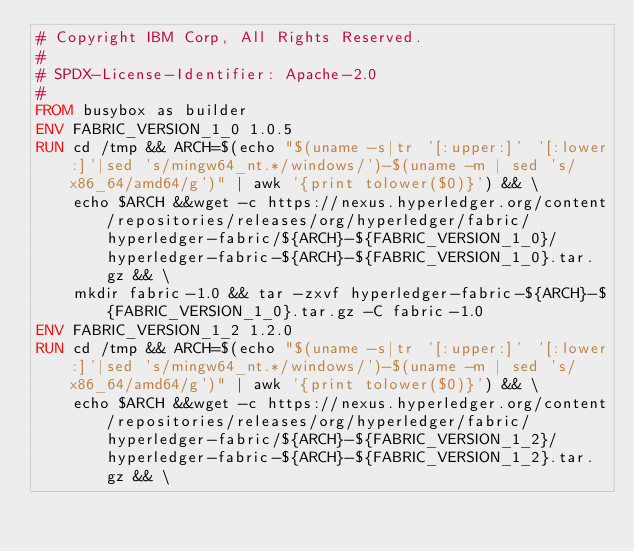Convert code to text. <code><loc_0><loc_0><loc_500><loc_500><_Dockerfile_># Copyright IBM Corp, All Rights Reserved.
#
# SPDX-License-Identifier: Apache-2.0
#
FROM busybox as builder
ENV FABRIC_VERSION_1_0 1.0.5
RUN cd /tmp && ARCH=$(echo "$(uname -s|tr '[:upper:]' '[:lower:]'|sed 's/mingw64_nt.*/windows/')-$(uname -m | sed 's/x86_64/amd64/g')" | awk '{print tolower($0)}') && \
    echo $ARCH &&wget -c https://nexus.hyperledger.org/content/repositories/releases/org/hyperledger/fabric/hyperledger-fabric/${ARCH}-${FABRIC_VERSION_1_0}/hyperledger-fabric-${ARCH}-${FABRIC_VERSION_1_0}.tar.gz && \
    mkdir fabric-1.0 && tar -zxvf hyperledger-fabric-${ARCH}-${FABRIC_VERSION_1_0}.tar.gz -C fabric-1.0
ENV FABRIC_VERSION_1_2 1.2.0
RUN cd /tmp && ARCH=$(echo "$(uname -s|tr '[:upper:]' '[:lower:]'|sed 's/mingw64_nt.*/windows/')-$(uname -m | sed 's/x86_64/amd64/g')" | awk '{print tolower($0)}') && \
    echo $ARCH &&wget -c https://nexus.hyperledger.org/content/repositories/releases/org/hyperledger/fabric/hyperledger-fabric/${ARCH}-${FABRIC_VERSION_1_2}/hyperledger-fabric-${ARCH}-${FABRIC_VERSION_1_2}.tar.gz && \</code> 